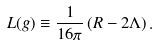<formula> <loc_0><loc_0><loc_500><loc_500>L ( g ) \equiv \frac { 1 } { 1 6 \pi } \, ( R - 2 \Lambda ) \, .</formula> 